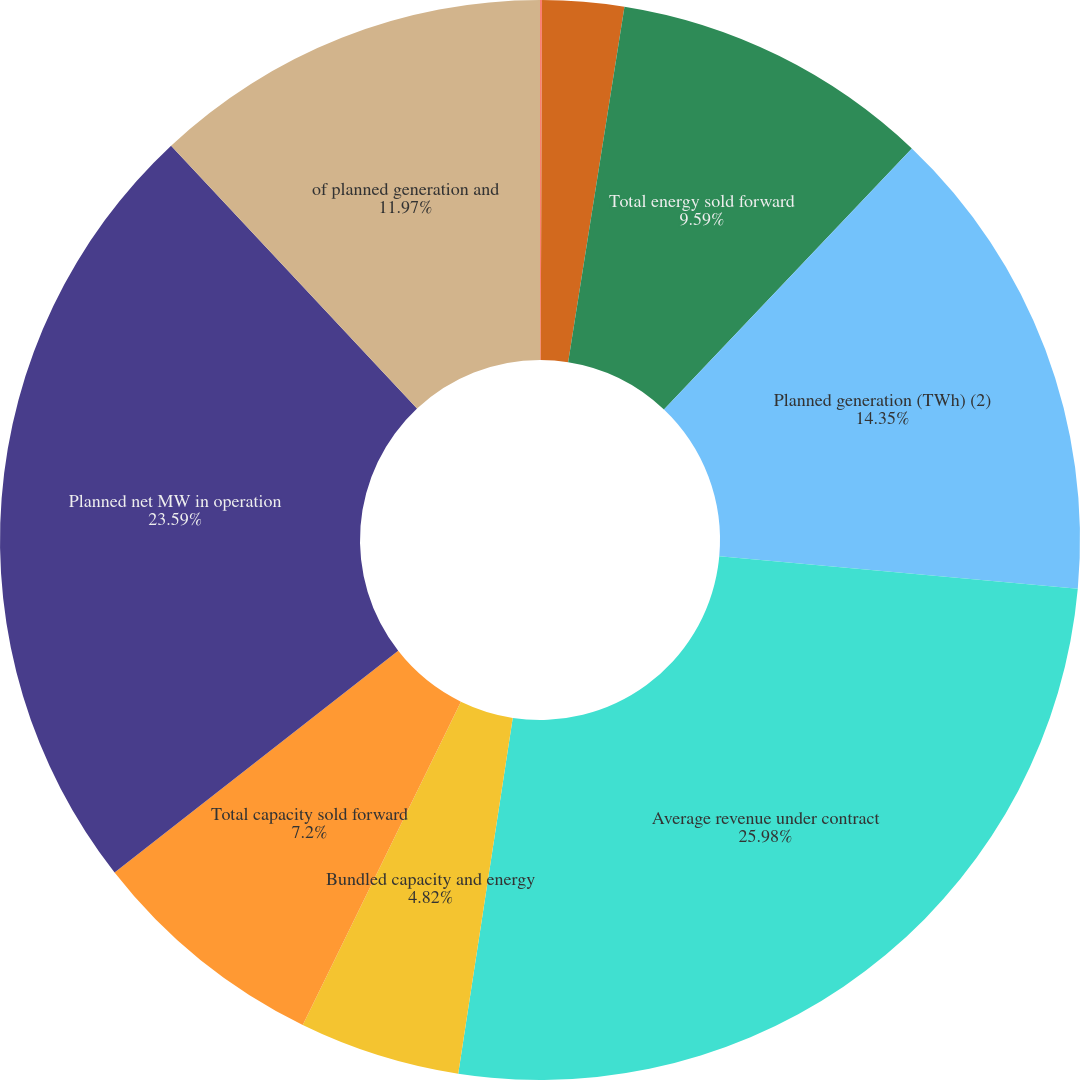Convert chart to OTSL. <chart><loc_0><loc_0><loc_500><loc_500><pie_chart><fcel>Unit-contingent<fcel>Unit-contingent with guarantee<fcel>Total energy sold forward<fcel>Planned generation (TWh) (2)<fcel>Average revenue under contract<fcel>Bundled capacity and energy<fcel>Total capacity sold forward<fcel>Planned net MW in operation<fcel>of planned generation and<nl><fcel>0.06%<fcel>2.44%<fcel>9.59%<fcel>14.35%<fcel>25.98%<fcel>4.82%<fcel>7.2%<fcel>23.59%<fcel>11.97%<nl></chart> 